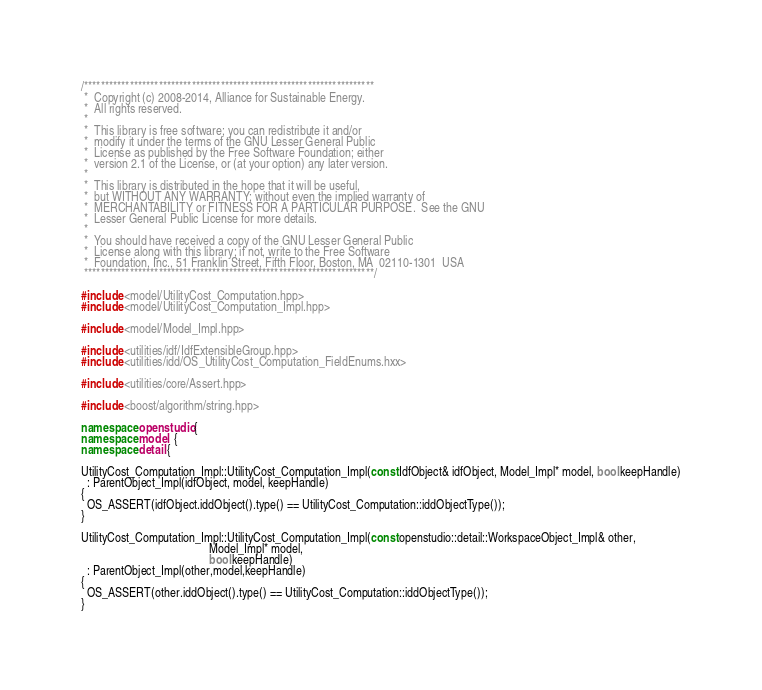Convert code to text. <code><loc_0><loc_0><loc_500><loc_500><_C++_>/**********************************************************************
 *  Copyright (c) 2008-2014, Alliance for Sustainable Energy.
 *  All rights reserved.
 *
 *  This library is free software; you can redistribute it and/or
 *  modify it under the terms of the GNU Lesser General Public
 *  License as published by the Free Software Foundation; either
 *  version 2.1 of the License, or (at your option) any later version.
 *
 *  This library is distributed in the hope that it will be useful,
 *  but WITHOUT ANY WARRANTY; without even the implied warranty of
 *  MERCHANTABILITY or FITNESS FOR A PARTICULAR PURPOSE.  See the GNU
 *  Lesser General Public License for more details.
 *
 *  You should have received a copy of the GNU Lesser General Public
 *  License along with this library; if not, write to the Free Software
 *  Foundation, Inc., 51 Franklin Street, Fifth Floor, Boston, MA  02110-1301  USA
 **********************************************************************/

#include <model/UtilityCost_Computation.hpp>
#include <model/UtilityCost_Computation_Impl.hpp>

#include <model/Model_Impl.hpp>

#include <utilities/idf/IdfExtensibleGroup.hpp>
#include <utilities/idd/OS_UtilityCost_Computation_FieldEnums.hxx>

#include <utilities/core/Assert.hpp>

#include <boost/algorithm/string.hpp>

namespace openstudio {
namespace model  {
namespace detail {

UtilityCost_Computation_Impl::UtilityCost_Computation_Impl(const IdfObject& idfObject, Model_Impl* model, bool keepHandle)
  : ParentObject_Impl(idfObject, model, keepHandle)
{
  OS_ASSERT(idfObject.iddObject().type() == UtilityCost_Computation::iddObjectType());
}

UtilityCost_Computation_Impl::UtilityCost_Computation_Impl(const openstudio::detail::WorkspaceObject_Impl& other,
                                           Model_Impl* model,
                                           bool keepHandle)
  : ParentObject_Impl(other,model,keepHandle)
{
  OS_ASSERT(other.iddObject().type() == UtilityCost_Computation::iddObjectType());
}
</code> 